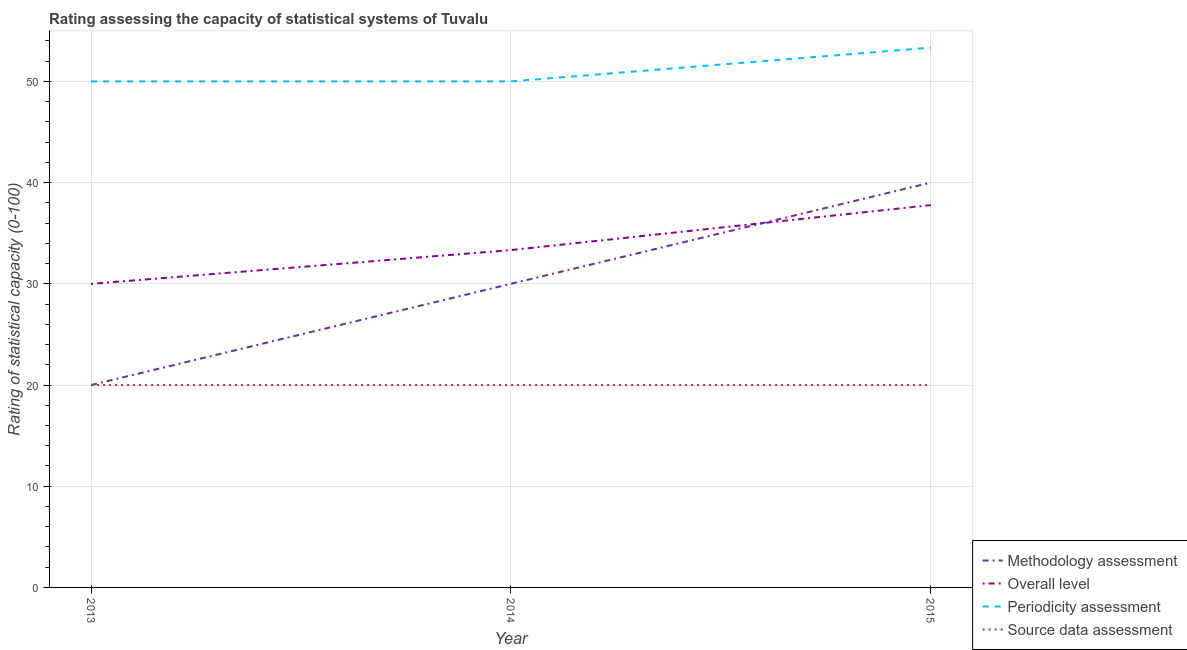Does the line corresponding to methodology assessment rating intersect with the line corresponding to overall level rating?
Your response must be concise. Yes. What is the source data assessment rating in 2015?
Your answer should be very brief. 20. Across all years, what is the maximum periodicity assessment rating?
Your answer should be very brief. 53.33. Across all years, what is the minimum periodicity assessment rating?
Your response must be concise. 50. In which year was the overall level rating maximum?
Your response must be concise. 2015. In which year was the overall level rating minimum?
Your response must be concise. 2013. What is the total periodicity assessment rating in the graph?
Offer a very short reply. 153.33. What is the difference between the methodology assessment rating in 2014 and that in 2015?
Ensure brevity in your answer.  -10. What is the difference between the methodology assessment rating in 2014 and the periodicity assessment rating in 2013?
Make the answer very short. -20. What is the average overall level rating per year?
Provide a short and direct response. 33.7. In the year 2014, what is the difference between the periodicity assessment rating and overall level rating?
Your answer should be very brief. 16.67. In how many years, is the periodicity assessment rating greater than 46?
Offer a very short reply. 3. What is the ratio of the overall level rating in 2014 to that in 2015?
Ensure brevity in your answer.  0.88. Is the difference between the overall level rating in 2013 and 2015 greater than the difference between the periodicity assessment rating in 2013 and 2015?
Your answer should be compact. No. What is the difference between the highest and the second highest methodology assessment rating?
Offer a terse response. 10. What is the difference between the highest and the lowest methodology assessment rating?
Make the answer very short. 20. Is the sum of the source data assessment rating in 2013 and 2014 greater than the maximum overall level rating across all years?
Offer a very short reply. Yes. Is it the case that in every year, the sum of the methodology assessment rating and overall level rating is greater than the periodicity assessment rating?
Your answer should be compact. No. Is the periodicity assessment rating strictly greater than the source data assessment rating over the years?
Your answer should be very brief. Yes. How many lines are there?
Your answer should be very brief. 4. What is the difference between two consecutive major ticks on the Y-axis?
Ensure brevity in your answer.  10. Are the values on the major ticks of Y-axis written in scientific E-notation?
Your answer should be compact. No. Does the graph contain any zero values?
Offer a very short reply. No. Does the graph contain grids?
Your answer should be very brief. Yes. How many legend labels are there?
Provide a succinct answer. 4. How are the legend labels stacked?
Provide a succinct answer. Vertical. What is the title of the graph?
Keep it short and to the point. Rating assessing the capacity of statistical systems of Tuvalu. Does "UNHCR" appear as one of the legend labels in the graph?
Provide a succinct answer. No. What is the label or title of the X-axis?
Give a very brief answer. Year. What is the label or title of the Y-axis?
Give a very brief answer. Rating of statistical capacity (0-100). What is the Rating of statistical capacity (0-100) of Periodicity assessment in 2013?
Offer a very short reply. 50. What is the Rating of statistical capacity (0-100) in Overall level in 2014?
Your answer should be very brief. 33.33. What is the Rating of statistical capacity (0-100) in Overall level in 2015?
Your answer should be very brief. 37.78. What is the Rating of statistical capacity (0-100) of Periodicity assessment in 2015?
Your answer should be very brief. 53.33. Across all years, what is the maximum Rating of statistical capacity (0-100) of Methodology assessment?
Provide a succinct answer. 40. Across all years, what is the maximum Rating of statistical capacity (0-100) of Overall level?
Ensure brevity in your answer.  37.78. Across all years, what is the maximum Rating of statistical capacity (0-100) in Periodicity assessment?
Offer a very short reply. 53.33. Across all years, what is the maximum Rating of statistical capacity (0-100) in Source data assessment?
Provide a short and direct response. 20. Across all years, what is the minimum Rating of statistical capacity (0-100) of Methodology assessment?
Give a very brief answer. 20. Across all years, what is the minimum Rating of statistical capacity (0-100) in Overall level?
Ensure brevity in your answer.  30. Across all years, what is the minimum Rating of statistical capacity (0-100) of Periodicity assessment?
Give a very brief answer. 50. What is the total Rating of statistical capacity (0-100) of Methodology assessment in the graph?
Provide a short and direct response. 90. What is the total Rating of statistical capacity (0-100) in Overall level in the graph?
Give a very brief answer. 101.11. What is the total Rating of statistical capacity (0-100) of Periodicity assessment in the graph?
Make the answer very short. 153.33. What is the total Rating of statistical capacity (0-100) in Source data assessment in the graph?
Ensure brevity in your answer.  60. What is the difference between the Rating of statistical capacity (0-100) in Overall level in 2013 and that in 2014?
Provide a succinct answer. -3.33. What is the difference between the Rating of statistical capacity (0-100) in Overall level in 2013 and that in 2015?
Your answer should be compact. -7.78. What is the difference between the Rating of statistical capacity (0-100) in Periodicity assessment in 2013 and that in 2015?
Provide a short and direct response. -3.33. What is the difference between the Rating of statistical capacity (0-100) of Source data assessment in 2013 and that in 2015?
Your response must be concise. 0. What is the difference between the Rating of statistical capacity (0-100) in Methodology assessment in 2014 and that in 2015?
Your answer should be very brief. -10. What is the difference between the Rating of statistical capacity (0-100) in Overall level in 2014 and that in 2015?
Provide a short and direct response. -4.44. What is the difference between the Rating of statistical capacity (0-100) in Source data assessment in 2014 and that in 2015?
Your response must be concise. 0. What is the difference between the Rating of statistical capacity (0-100) of Methodology assessment in 2013 and the Rating of statistical capacity (0-100) of Overall level in 2014?
Give a very brief answer. -13.33. What is the difference between the Rating of statistical capacity (0-100) of Methodology assessment in 2013 and the Rating of statistical capacity (0-100) of Overall level in 2015?
Provide a succinct answer. -17.78. What is the difference between the Rating of statistical capacity (0-100) of Methodology assessment in 2013 and the Rating of statistical capacity (0-100) of Periodicity assessment in 2015?
Provide a short and direct response. -33.33. What is the difference between the Rating of statistical capacity (0-100) of Methodology assessment in 2013 and the Rating of statistical capacity (0-100) of Source data assessment in 2015?
Provide a short and direct response. 0. What is the difference between the Rating of statistical capacity (0-100) in Overall level in 2013 and the Rating of statistical capacity (0-100) in Periodicity assessment in 2015?
Make the answer very short. -23.33. What is the difference between the Rating of statistical capacity (0-100) of Overall level in 2013 and the Rating of statistical capacity (0-100) of Source data assessment in 2015?
Your answer should be compact. 10. What is the difference between the Rating of statistical capacity (0-100) in Methodology assessment in 2014 and the Rating of statistical capacity (0-100) in Overall level in 2015?
Your response must be concise. -7.78. What is the difference between the Rating of statistical capacity (0-100) in Methodology assessment in 2014 and the Rating of statistical capacity (0-100) in Periodicity assessment in 2015?
Offer a very short reply. -23.33. What is the difference between the Rating of statistical capacity (0-100) of Methodology assessment in 2014 and the Rating of statistical capacity (0-100) of Source data assessment in 2015?
Provide a short and direct response. 10. What is the difference between the Rating of statistical capacity (0-100) of Overall level in 2014 and the Rating of statistical capacity (0-100) of Source data assessment in 2015?
Give a very brief answer. 13.33. What is the difference between the Rating of statistical capacity (0-100) of Periodicity assessment in 2014 and the Rating of statistical capacity (0-100) of Source data assessment in 2015?
Your answer should be very brief. 30. What is the average Rating of statistical capacity (0-100) of Methodology assessment per year?
Provide a short and direct response. 30. What is the average Rating of statistical capacity (0-100) in Overall level per year?
Keep it short and to the point. 33.7. What is the average Rating of statistical capacity (0-100) of Periodicity assessment per year?
Your answer should be very brief. 51.11. In the year 2013, what is the difference between the Rating of statistical capacity (0-100) in Methodology assessment and Rating of statistical capacity (0-100) in Overall level?
Provide a short and direct response. -10. In the year 2013, what is the difference between the Rating of statistical capacity (0-100) of Methodology assessment and Rating of statistical capacity (0-100) of Periodicity assessment?
Your response must be concise. -30. In the year 2013, what is the difference between the Rating of statistical capacity (0-100) of Methodology assessment and Rating of statistical capacity (0-100) of Source data assessment?
Provide a short and direct response. 0. In the year 2013, what is the difference between the Rating of statistical capacity (0-100) in Overall level and Rating of statistical capacity (0-100) in Periodicity assessment?
Keep it short and to the point. -20. In the year 2013, what is the difference between the Rating of statistical capacity (0-100) in Overall level and Rating of statistical capacity (0-100) in Source data assessment?
Ensure brevity in your answer.  10. In the year 2013, what is the difference between the Rating of statistical capacity (0-100) in Periodicity assessment and Rating of statistical capacity (0-100) in Source data assessment?
Provide a short and direct response. 30. In the year 2014, what is the difference between the Rating of statistical capacity (0-100) in Methodology assessment and Rating of statistical capacity (0-100) in Overall level?
Provide a succinct answer. -3.33. In the year 2014, what is the difference between the Rating of statistical capacity (0-100) of Methodology assessment and Rating of statistical capacity (0-100) of Periodicity assessment?
Your answer should be compact. -20. In the year 2014, what is the difference between the Rating of statistical capacity (0-100) in Overall level and Rating of statistical capacity (0-100) in Periodicity assessment?
Your answer should be compact. -16.67. In the year 2014, what is the difference between the Rating of statistical capacity (0-100) in Overall level and Rating of statistical capacity (0-100) in Source data assessment?
Your answer should be compact. 13.33. In the year 2014, what is the difference between the Rating of statistical capacity (0-100) of Periodicity assessment and Rating of statistical capacity (0-100) of Source data assessment?
Ensure brevity in your answer.  30. In the year 2015, what is the difference between the Rating of statistical capacity (0-100) of Methodology assessment and Rating of statistical capacity (0-100) of Overall level?
Your response must be concise. 2.22. In the year 2015, what is the difference between the Rating of statistical capacity (0-100) of Methodology assessment and Rating of statistical capacity (0-100) of Periodicity assessment?
Your answer should be compact. -13.33. In the year 2015, what is the difference between the Rating of statistical capacity (0-100) of Overall level and Rating of statistical capacity (0-100) of Periodicity assessment?
Your answer should be compact. -15.56. In the year 2015, what is the difference between the Rating of statistical capacity (0-100) in Overall level and Rating of statistical capacity (0-100) in Source data assessment?
Offer a very short reply. 17.78. In the year 2015, what is the difference between the Rating of statistical capacity (0-100) in Periodicity assessment and Rating of statistical capacity (0-100) in Source data assessment?
Keep it short and to the point. 33.33. What is the ratio of the Rating of statistical capacity (0-100) in Periodicity assessment in 2013 to that in 2014?
Your response must be concise. 1. What is the ratio of the Rating of statistical capacity (0-100) of Overall level in 2013 to that in 2015?
Offer a terse response. 0.79. What is the ratio of the Rating of statistical capacity (0-100) in Source data assessment in 2013 to that in 2015?
Your answer should be very brief. 1. What is the ratio of the Rating of statistical capacity (0-100) of Overall level in 2014 to that in 2015?
Offer a terse response. 0.88. What is the difference between the highest and the second highest Rating of statistical capacity (0-100) in Methodology assessment?
Offer a very short reply. 10. What is the difference between the highest and the second highest Rating of statistical capacity (0-100) in Overall level?
Give a very brief answer. 4.44. What is the difference between the highest and the second highest Rating of statistical capacity (0-100) in Periodicity assessment?
Your response must be concise. 3.33. What is the difference between the highest and the second highest Rating of statistical capacity (0-100) of Source data assessment?
Provide a short and direct response. 0. What is the difference between the highest and the lowest Rating of statistical capacity (0-100) of Overall level?
Offer a terse response. 7.78. What is the difference between the highest and the lowest Rating of statistical capacity (0-100) of Periodicity assessment?
Give a very brief answer. 3.33. 